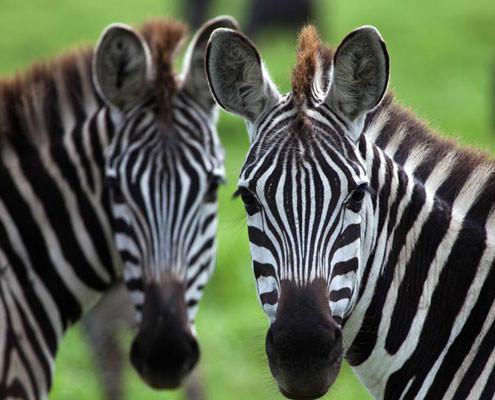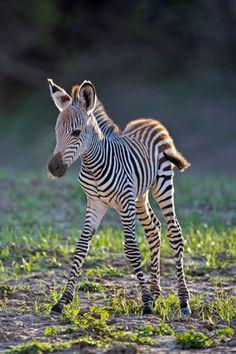The first image is the image on the left, the second image is the image on the right. For the images displayed, is the sentence "Two zebras are standing near each other in both pictures." factually correct? Answer yes or no. No. The first image is the image on the left, the second image is the image on the right. Evaluate the accuracy of this statement regarding the images: "Each image contains exactly two zebras, and at least one image features two zebras standing one in front of the other and facing the same direction.". Is it true? Answer yes or no. No. 